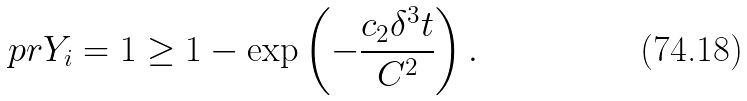<formula> <loc_0><loc_0><loc_500><loc_500>\ p r { Y _ { i } = 1 } \geq 1 - \exp \left ( - \frac { c _ { 2 } \delta ^ { 3 } t } { C ^ { 2 } } \right ) .</formula> 